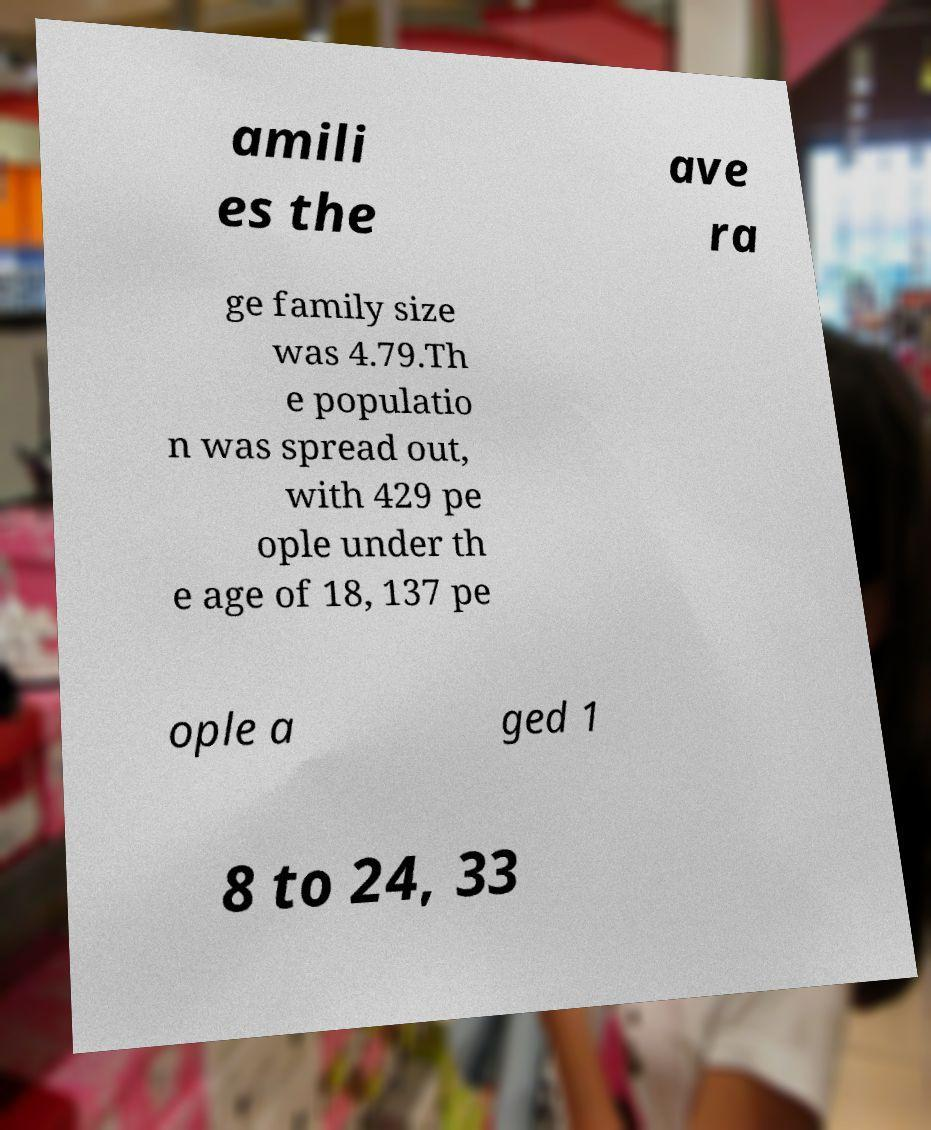I need the written content from this picture converted into text. Can you do that? amili es the ave ra ge family size was 4.79.Th e populatio n was spread out, with 429 pe ople under th e age of 18, 137 pe ople a ged 1 8 to 24, 33 